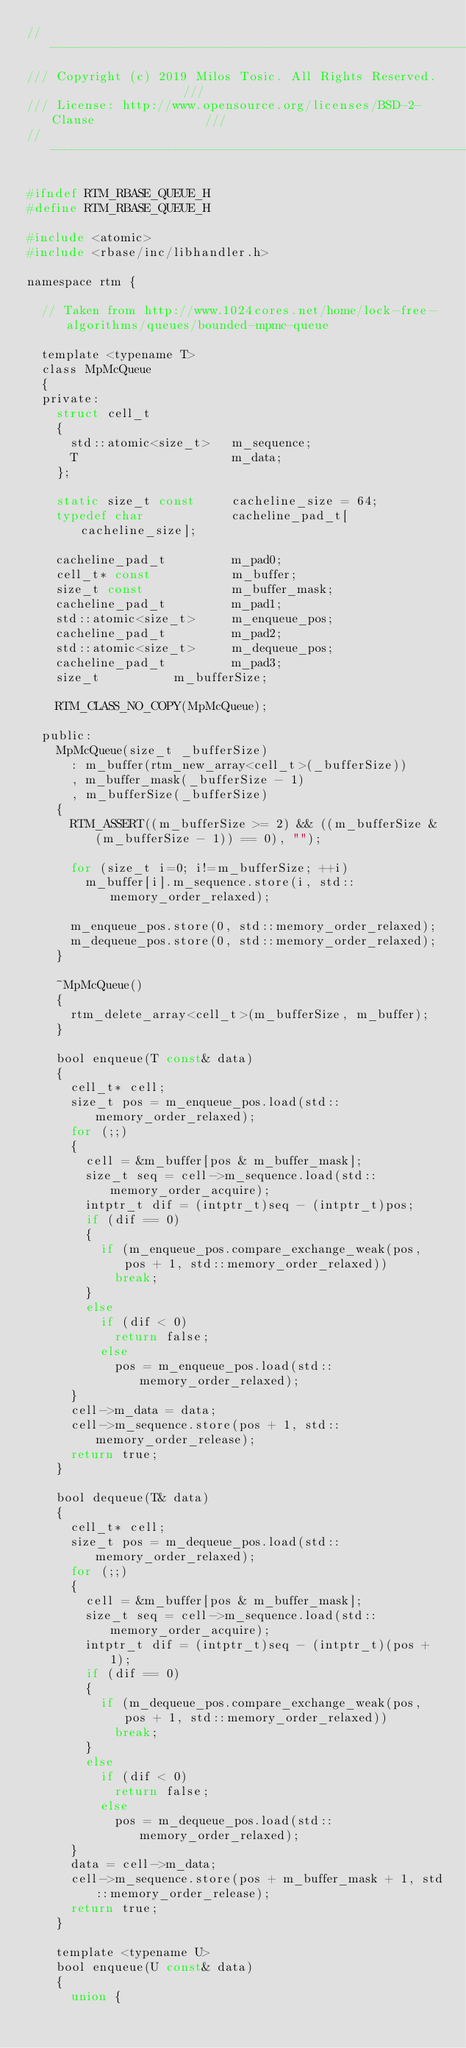Convert code to text. <code><loc_0><loc_0><loc_500><loc_500><_C_>//--------------------------------------------------------------------------//
/// Copyright (c) 2019 Milos Tosic. All Rights Reserved.                   ///
/// License: http://www.opensource.org/licenses/BSD-2-Clause               ///
//--------------------------------------------------------------------------//

#ifndef RTM_RBASE_QUEUE_H
#define RTM_RBASE_QUEUE_H

#include <atomic>
#include <rbase/inc/libhandler.h>

namespace rtm {

	// Taken from http://www.1024cores.net/home/lock-free-algorithms/queues/bounded-mpmc-queue

	template <typename T>
	class MpMcQueue
	{
	private:
		struct cell_t
		{
			std::atomic<size_t>   m_sequence;
			T                     m_data;
		};

		static size_t const     cacheline_size = 64;
		typedef char            cacheline_pad_t[cacheline_size];

		cacheline_pad_t         m_pad0;
		cell_t* const           m_buffer;
		size_t const            m_buffer_mask;
		cacheline_pad_t         m_pad1;
		std::atomic<size_t>     m_enqueue_pos;
		cacheline_pad_t         m_pad2;
		std::atomic<size_t>     m_dequeue_pos;
		cacheline_pad_t         m_pad3;
		size_t					m_bufferSize;

		RTM_CLASS_NO_COPY(MpMcQueue);

	public:
		MpMcQueue(size_t _bufferSize)
			: m_buffer(rtm_new_array<cell_t>(_bufferSize))
			, m_buffer_mask(_bufferSize - 1)
			, m_bufferSize(_bufferSize)
		{
			RTM_ASSERT((m_bufferSize >= 2) && ((m_bufferSize & (m_bufferSize - 1)) == 0), "");

			for (size_t i=0; i!=m_bufferSize; ++i)
				m_buffer[i].m_sequence.store(i, std::memory_order_relaxed);

			m_enqueue_pos.store(0, std::memory_order_relaxed);
			m_dequeue_pos.store(0, std::memory_order_relaxed);
		}

		~MpMcQueue()
		{
			rtm_delete_array<cell_t>(m_bufferSize, m_buffer);
		}

		bool enqueue(T const& data)
		{
			cell_t* cell;
			size_t pos = m_enqueue_pos.load(std::memory_order_relaxed);
			for (;;)
			{
				cell = &m_buffer[pos & m_buffer_mask];
				size_t seq = cell->m_sequence.load(std::memory_order_acquire);
				intptr_t dif = (intptr_t)seq - (intptr_t)pos;
				if (dif == 0)
				{
					if (m_enqueue_pos.compare_exchange_weak(pos, pos + 1, std::memory_order_relaxed))
						break;
				}
				else
					if (dif < 0)
						return false;
					else
						pos = m_enqueue_pos.load(std::memory_order_relaxed);
			}
			cell->m_data = data;
			cell->m_sequence.store(pos + 1, std::memory_order_release);
			return true;
		}

		bool dequeue(T& data)
		{
			cell_t* cell;
			size_t pos = m_dequeue_pos.load(std::memory_order_relaxed);
			for (;;)
			{
				cell = &m_buffer[pos & m_buffer_mask];
				size_t seq = cell->m_sequence.load(std::memory_order_acquire);
				intptr_t dif = (intptr_t)seq - (intptr_t)(pos + 1);
				if (dif == 0)
				{
					if (m_dequeue_pos.compare_exchange_weak(pos, pos + 1, std::memory_order_relaxed))
						break;
				}
				else
					if (dif < 0)
						return false;
					else
						pos = m_dequeue_pos.load(std::memory_order_relaxed);
			}
			data = cell->m_data;
			cell->m_sequence.store(pos + m_buffer_mask + 1, std::memory_order_release);
			return true;
		}

		template <typename U>
		bool enqueue(U const& data)
		{
			union {</code> 